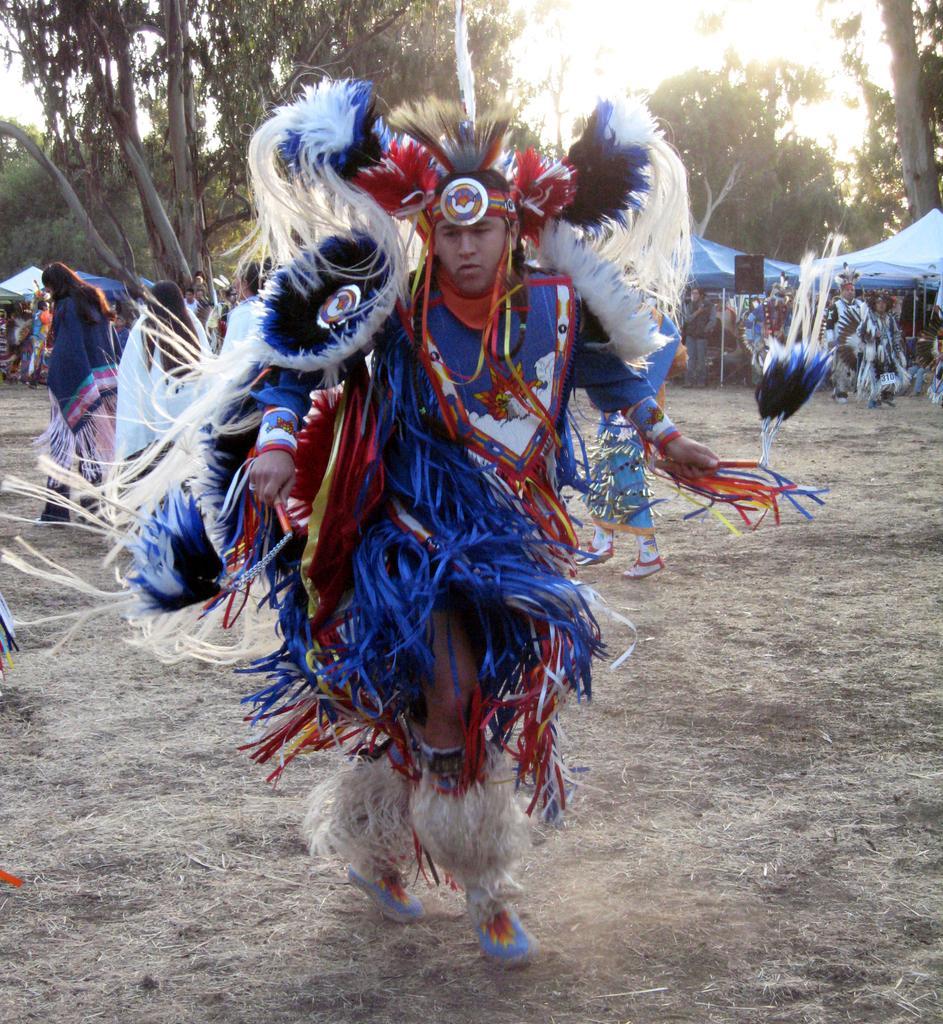Could you give a brief overview of what you see in this image? In the image we can see the person standing wearing a costume, shoes and it looks like the person is dancing. Behind the person there are other people. We can even see the trees, dry grass and the sky. We can even see there are pole tents. 